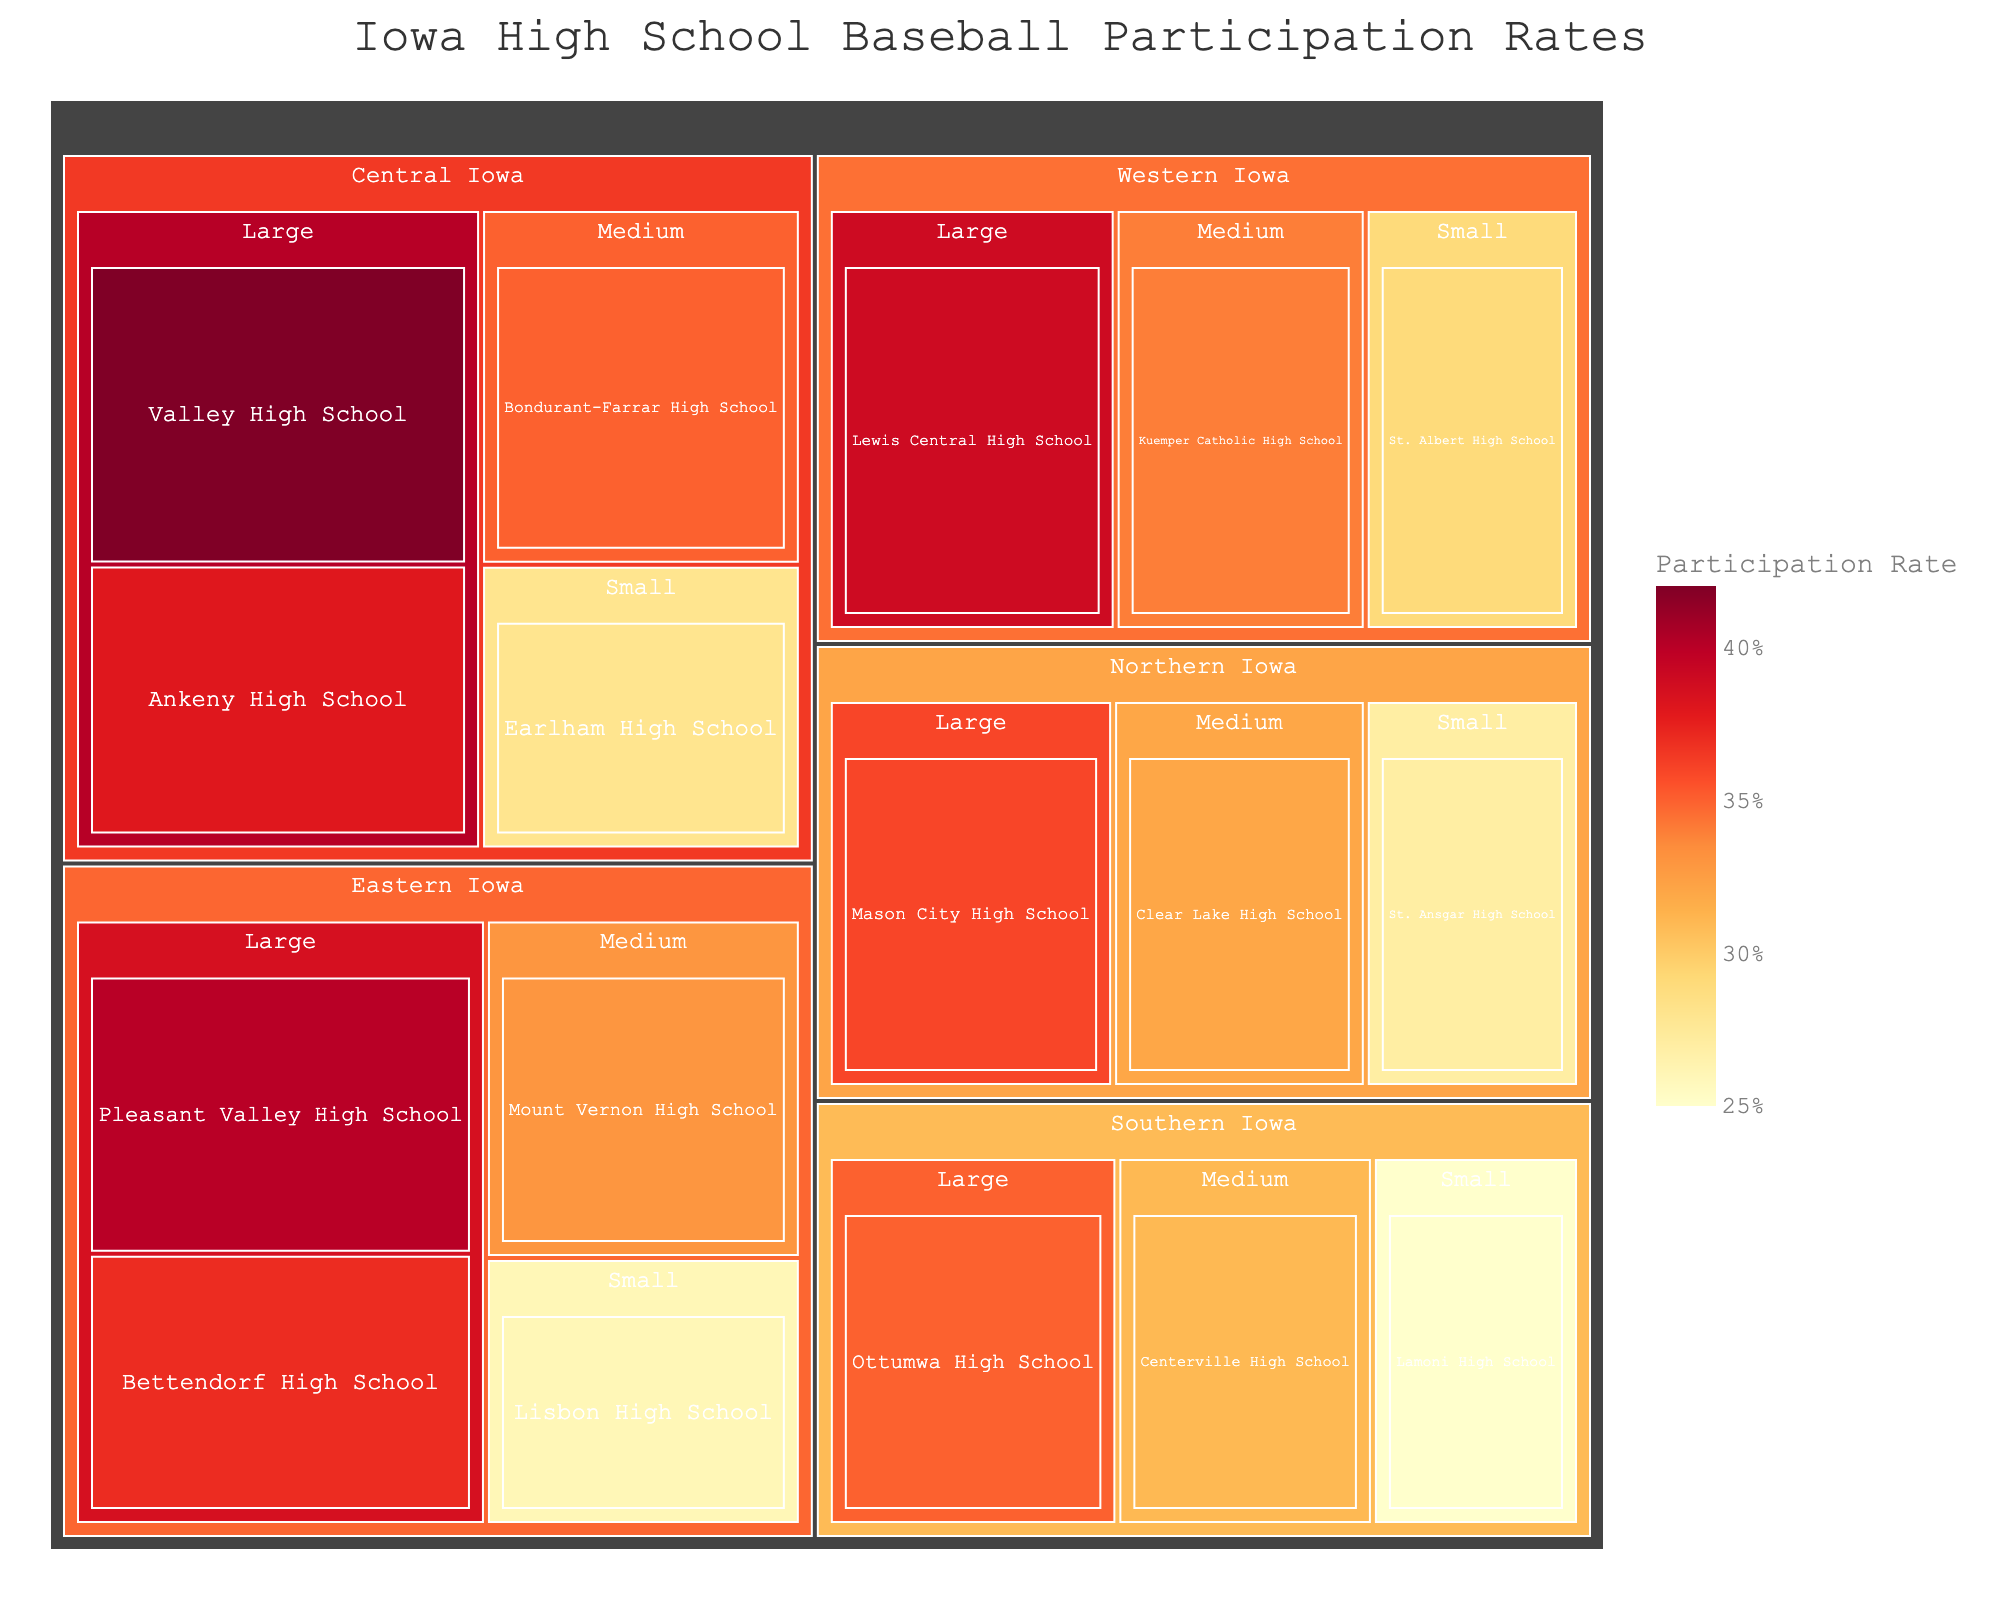Which region has the highest participation rate in a large school? Looking at the treemap, the color for Valley High School in Central Iowa is the darkest, indicating the highest value.
Answer: Central Iowa What is the participation rate for Pleasant Valley High School? Hovering over Pleasant Valley High School, we can see the participation rate.
Answer: 40% Which region has the smallest school with the highest participation rate? The treemap shows different schools within each region, and by comparing them, we see that St. Albert High School in Western Iowa has the darkest color among the small schools.
Answer: Western Iowa How does the participation rate of Ankeny High School compare to Bettendorf High School? Hovering over both Ankeny High School (38%) and Bettendorf High School (37%), we see that Ankeny High School has a slightly higher participation rate.
Answer: Ankeny High School is higher What's the average participation rate for small schools in Eastern Iowa? The rates for small schools in Eastern Iowa are listed, and adding them, we get 26 (Lisbon High School). There's only one small school in Eastern Iowa in the dataset, thus the average is the same as its participation rate.
Answer: 26 Among the medium-sized schools, which one has the lowest participation rate and in which region is it located? By inspecting the colors for medium-sized schools, Centerville High School in Southern Iowa has the lightest color, indicating the lowest rate among medium-sized schools.
Answer: Centerville High School, Southern Iowa Is there any school with a participation rate exactly at the median level? Listing all the participation rates and finding the median value: Sorting the rates, the middle value is 32, corresponding to Clear Lake High School.
Answer: Clear Lake High School Which does region have more schools with a participation rate greater than 35%? By counting, Central Iowa has most schools (Valley High School, Ankeny High School, Bondurant-Farrar High School).
Answer: Central Iowa How does the combined participation of large schools in Western Iowa compare to those in Northern Iowa? Summing the participation rates for Western Iowa's large schools (Lewis Central High School, 39) and Northern Iowa's large schools (Mason City High School, 36): 39 > 36.
Answer: Western Iowa is higher Which school has the closest participation rate to the overall average participation rate of all schools shown? First, calculate the overall average rate: (sum of all rates) ÷ (number of schools) = 524 ÷ 16 = 32.75. Comparing to individual rates, Clear Lake High School (32) is the closest.
Answer: Clear Lake High School 